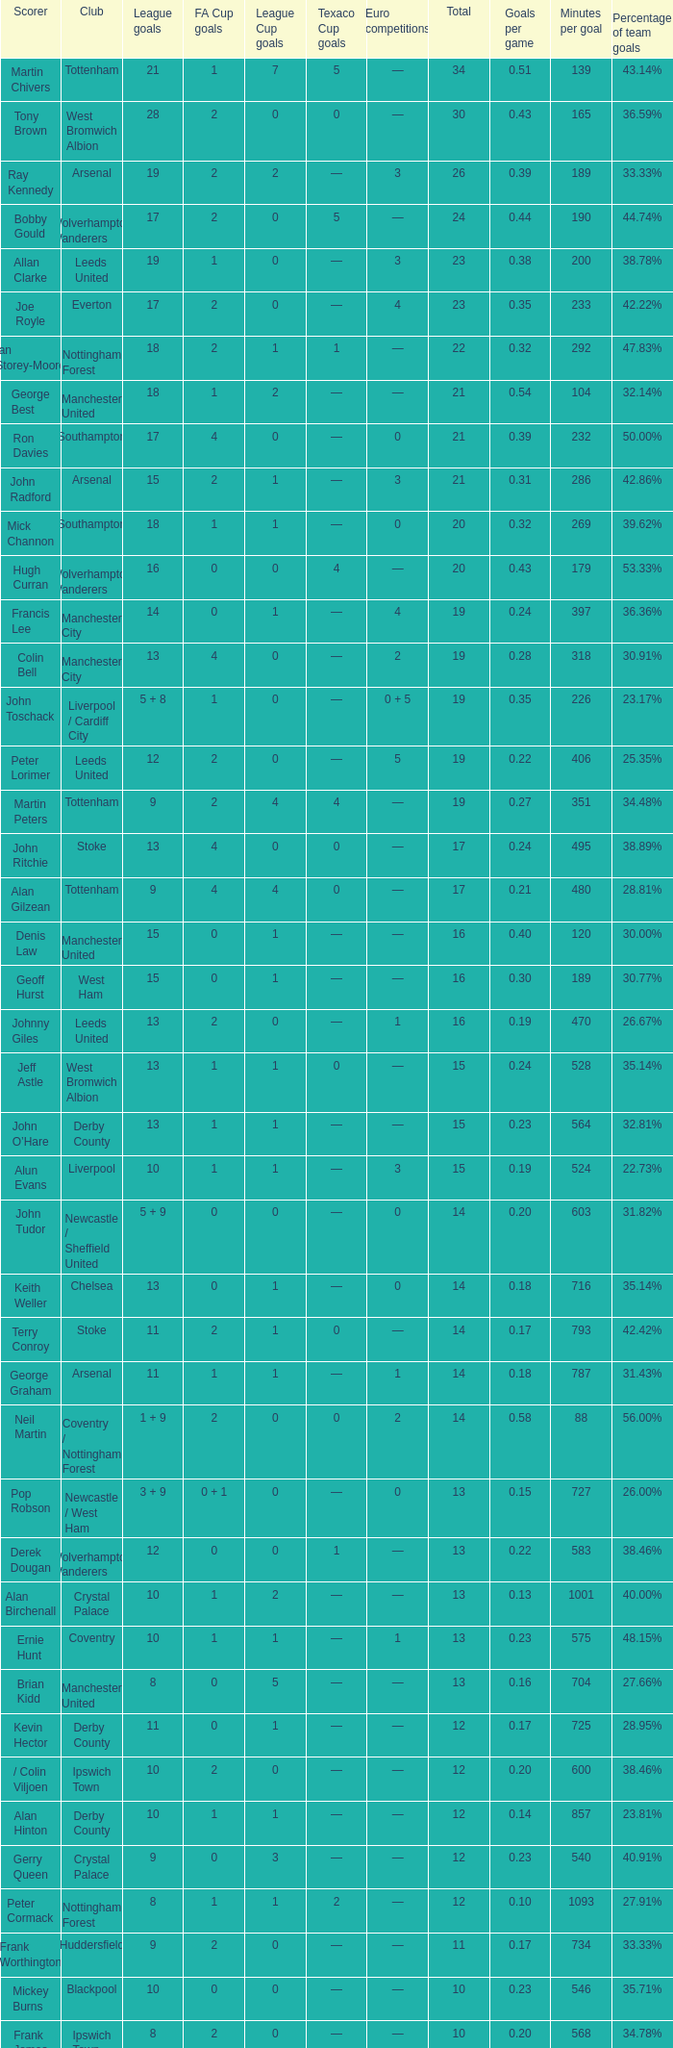What is the total number of Total, when Club is Leeds United, and when League Goals is 13? 1.0. 